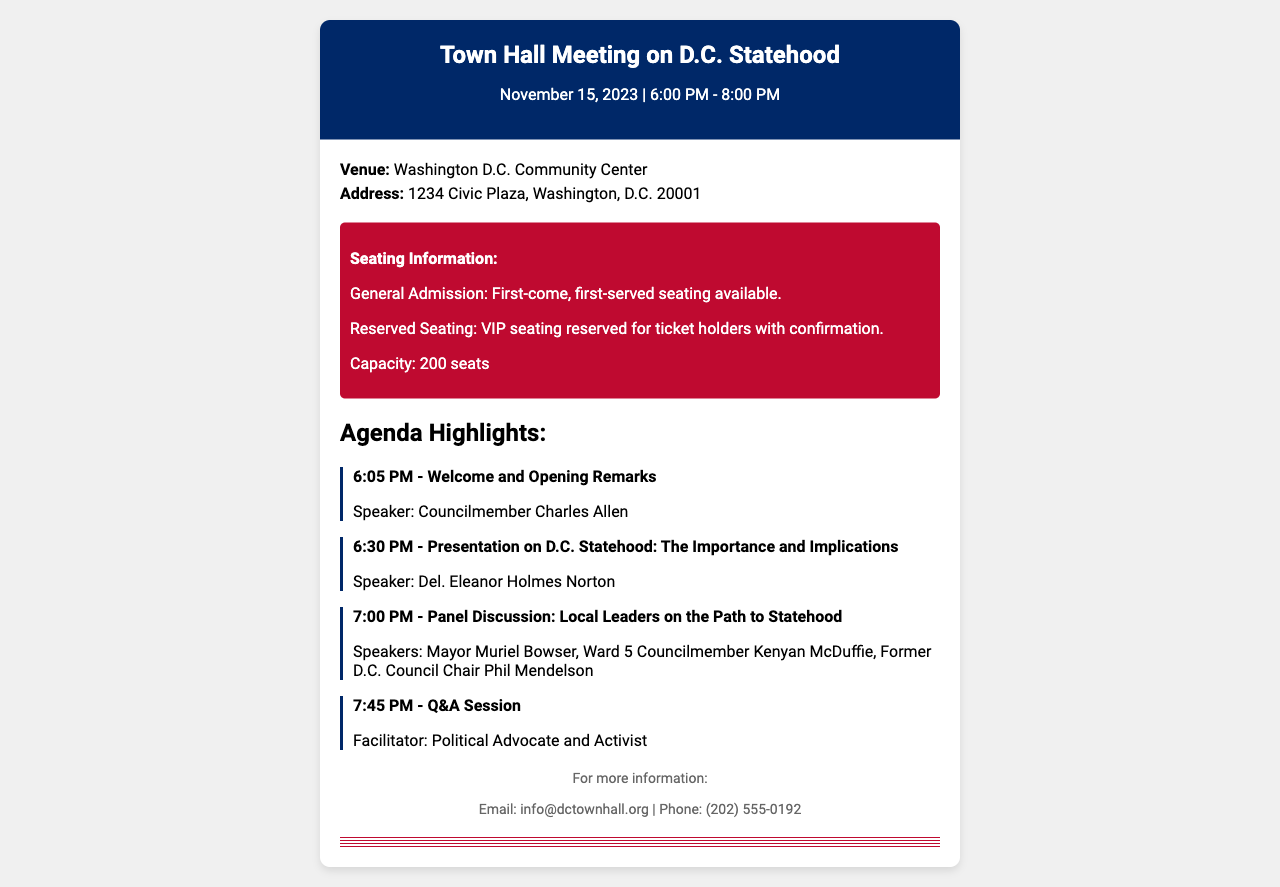What is the date of the town hall meeting? The date is specified in the document as November 15, 2023.
Answer: November 15, 2023 What time does the town hall meeting start? The start time is indicated as 6:00 PM in the event details.
Answer: 6:00 PM Where is the town hall meeting being held? The document lists the venue as Washington D.C. Community Center.
Answer: Washington D.C. Community Center Who is the speaker for the welcome and opening remarks? The speaker's name is provided as Councilmember Charles Allen in the agenda highlights.
Answer: Councilmember Charles Allen What is the capacity of the venue? The document states that the capacity is 200 seats.
Answer: 200 seats What type of seating is reserved for VIP ticket holders? The seating type for VIP holders is noted as reserved seating.
Answer: Reserved Seating What is the topic of the presentation at 6:30 PM? The topic is about D.C. Statehood: The Importance and Implications as per the agenda.
Answer: D.C. Statehood: The Importance and Implications Who will facilitate the Q&A session? The facilitator of the Q&A session is identified as a Political Advocate and Activist in the agenda.
Answer: Political Advocate and Activist What contact method is provided for more information? The document provides an email as a contact method for more information.
Answer: info@dctownhall.org 